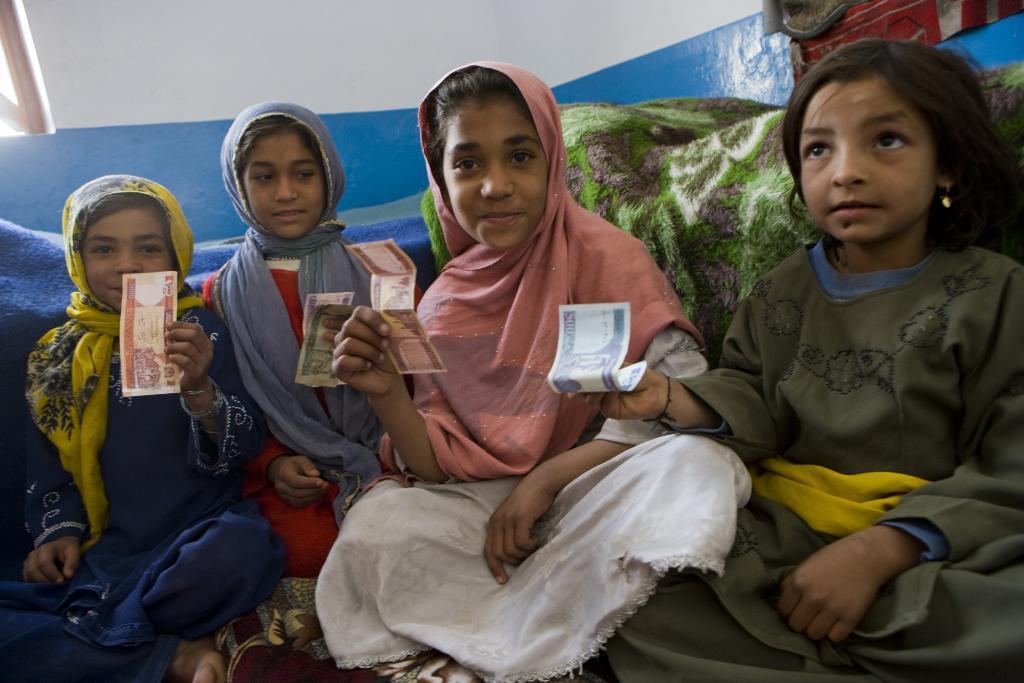Describe this image in one or two sentences. In this image I can see four children holding a paper and in the background I can see blankets visible in the background and at the top I can see the wall. 